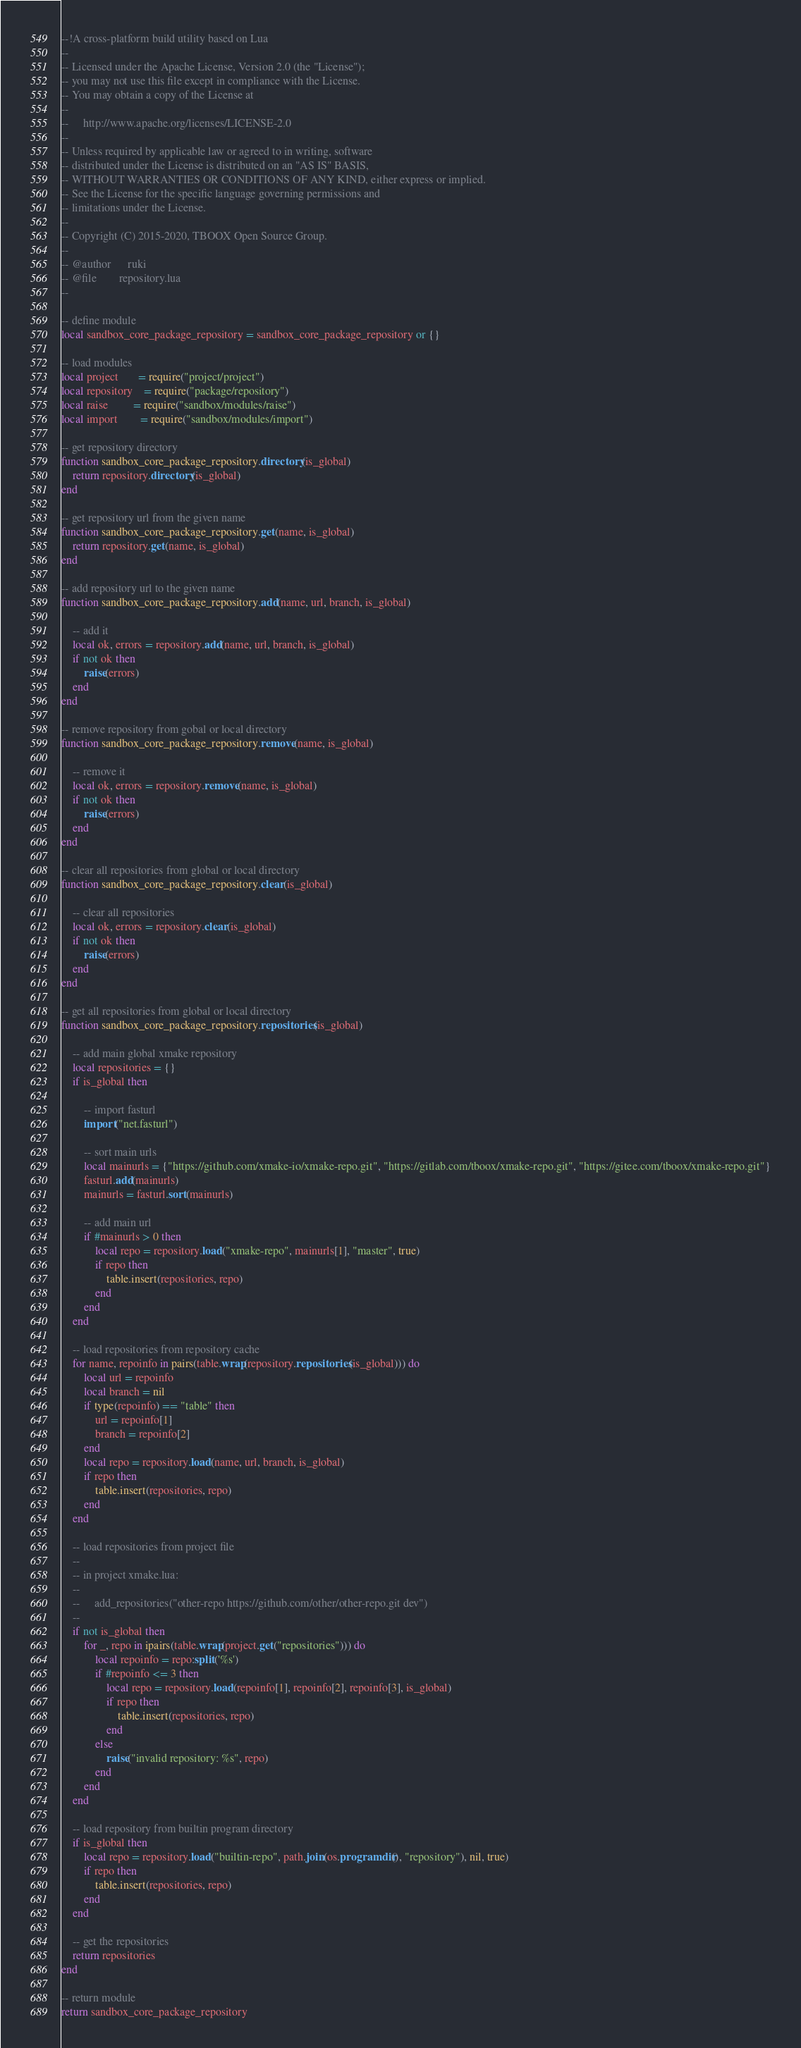Convert code to text. <code><loc_0><loc_0><loc_500><loc_500><_Lua_>--!A cross-platform build utility based on Lua
--
-- Licensed under the Apache License, Version 2.0 (the "License");
-- you may not use this file except in compliance with the License.
-- You may obtain a copy of the License at
--
--     http://www.apache.org/licenses/LICENSE-2.0
--
-- Unless required by applicable law or agreed to in writing, software
-- distributed under the License is distributed on an "AS IS" BASIS,
-- WITHOUT WARRANTIES OR CONDITIONS OF ANY KIND, either express or implied.
-- See the License for the specific language governing permissions and
-- limitations under the License.
-- 
-- Copyright (C) 2015-2020, TBOOX Open Source Group.
--
-- @author      ruki
-- @file        repository.lua
--

-- define module
local sandbox_core_package_repository = sandbox_core_package_repository or {}

-- load modules
local project       = require("project/project")
local repository    = require("package/repository")
local raise         = require("sandbox/modules/raise")
local import        = require("sandbox/modules/import")

-- get repository directory
function sandbox_core_package_repository.directory(is_global)
    return repository.directory(is_global)
end

-- get repository url from the given name
function sandbox_core_package_repository.get(name, is_global)
    return repository.get(name, is_global)
end

-- add repository url to the given name
function sandbox_core_package_repository.add(name, url, branch, is_global)

    -- add it
    local ok, errors = repository.add(name, url, branch, is_global)
    if not ok then
        raise(errors)
    end
end

-- remove repository from gobal or local directory
function sandbox_core_package_repository.remove(name, is_global)

    -- remove it
    local ok, errors = repository.remove(name, is_global)
    if not ok then
        raise(errors)
    end
end

-- clear all repositories from global or local directory
function sandbox_core_package_repository.clear(is_global)

    -- clear all repositories
    local ok, errors = repository.clear(is_global)
    if not ok then
        raise(errors)
    end
end

-- get all repositories from global or local directory
function sandbox_core_package_repository.repositories(is_global)

    -- add main global xmake repository
    local repositories = {}
    if is_global then

        -- import fasturl
        import("net.fasturl")

        -- sort main urls
        local mainurls = {"https://github.com/xmake-io/xmake-repo.git", "https://gitlab.com/tboox/xmake-repo.git", "https://gitee.com/tboox/xmake-repo.git"}
        fasturl.add(mainurls)
        mainurls = fasturl.sort(mainurls)

        -- add main url
        if #mainurls > 0 then
            local repo = repository.load("xmake-repo", mainurls[1], "master", true)
            if repo then
                table.insert(repositories, repo)
            end
        end
    end

    -- load repositories from repository cache 
    for name, repoinfo in pairs(table.wrap(repository.repositories(is_global))) do
        local url = repoinfo
        local branch = nil
        if type(repoinfo) == "table" then
            url = repoinfo[1]
            branch = repoinfo[2]
        end
        local repo = repository.load(name, url, branch, is_global)
        if repo then
            table.insert(repositories, repo)
        end
    end

    -- load repositories from project file
    --
    -- in project xmake.lua:
    --
    --     add_repositories("other-repo https://github.com/other/other-repo.git dev")
    --
    if not is_global then
        for _, repo in ipairs(table.wrap(project.get("repositories"))) do
            local repoinfo = repo:split('%s')
            if #repoinfo <= 3 then
                local repo = repository.load(repoinfo[1], repoinfo[2], repoinfo[3], is_global)
                if repo then
                    table.insert(repositories, repo)
                end
            else
                raise("invalid repository: %s", repo)
            end
        end
    end

    -- load repository from builtin program directory
    if is_global then
        local repo = repository.load("builtin-repo", path.join(os.programdir(), "repository"), nil, true)
        if repo then
            table.insert(repositories, repo)
        end
    end

    -- get the repositories
    return repositories
end

-- return module
return sandbox_core_package_repository
</code> 